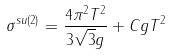Convert formula to latex. <formula><loc_0><loc_0><loc_500><loc_500>\sigma ^ { s u ( 2 ) } = \frac { 4 \pi ^ { 2 } T ^ { 2 } } { 3 \sqrt { 3 } g } + C g T ^ { 2 }</formula> 